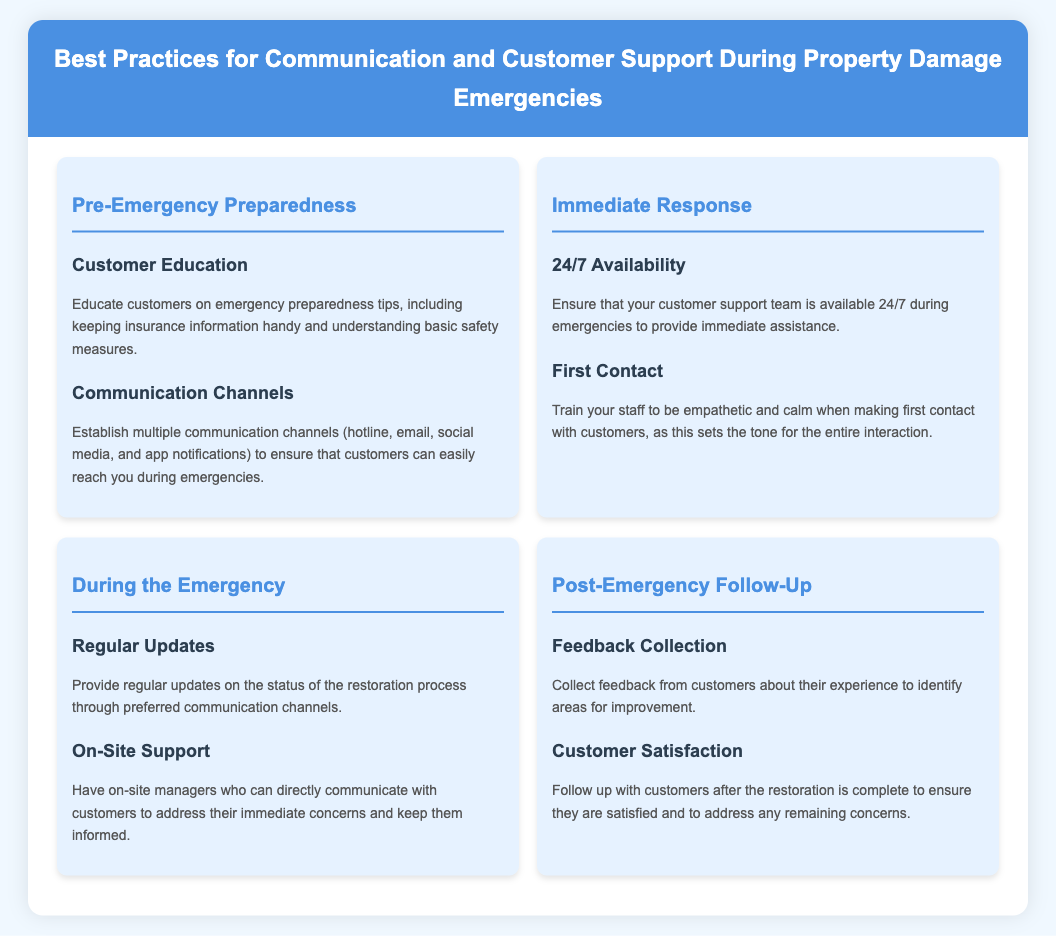What is the title of the infographic? The title is the main heading of the infographic, which summarizes its content.
Answer: Best Practices for Communication and Customer Support During Property Damage Emergencies How many sections are in the infographic? The sections cover different stages of emergencies and are structured distinctly; counting them provides the total.
Answer: Four What is included in the 'Pre-Emergency Preparedness' section? This section outlines the strategies that should be in place before an emergency occurs, specifically two practices.
Answer: Customer Education, Communication Channels Which best practice ensures support availability? This practice guarantees that assistance is accessible at all times, especially during emergencies.
Answer: 24/7 Availability What should be assessed during 'Post-Emergency Follow-Up'? This action focuses on understanding customer experiences and satisfaction after services have been rendered.
Answer: Feedback Collection, Customer Satisfaction What is a key focus during the 'Immediate Response' phase? This phase emphasizes the importance of initial contact after an emergency, which sets the tone for further interactions.
Answer: First Contact Which communication method is mentioned for providing updates? This method is crucial for keeping customers informed about their restoration progress during emergencies.
Answer: Regular Updates What type of communication channels should be established? These channels ensure customers have multiple methods through which they can contact support during crises.
Answer: Hotline, Email, Social Media, App Notifications 